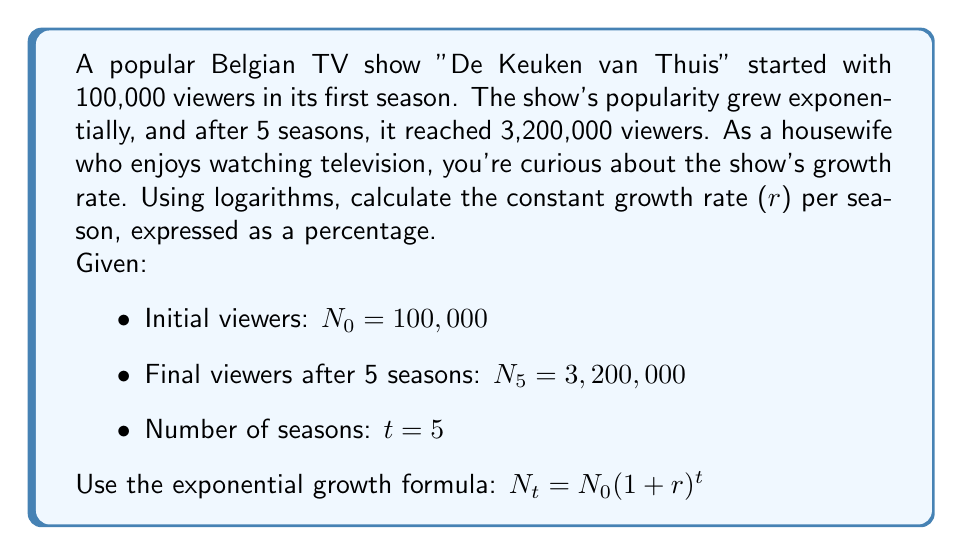Can you solve this math problem? Let's solve this step-by-step using logarithms:

1) Start with the exponential growth formula:
   $N_t = N_0(1+r)^t$

2) Substitute the known values:
   $3,200,000 = 100,000(1+r)^5$

3) Divide both sides by 100,000:
   $32 = (1+r)^5$

4) Take the natural logarithm of both sides:
   $\ln(32) = \ln((1+r)^5)$

5) Use the logarithm property $\ln(a^b) = b\ln(a)$:
   $\ln(32) = 5\ln(1+r)$

6) Divide both sides by 5:
   $\frac{\ln(32)}{5} = \ln(1+r)$

7) Apply the exponential function to both sides:
   $e^{\frac{\ln(32)}{5}} = e^{\ln(1+r)} = 1+r$

8) Subtract 1 from both sides:
   $e^{\frac{\ln(32)}{5}} - 1 = r$

9) Calculate the value:
   $r = e^{\frac{\ln(32)}{5}} - 1 \approx 0.2623$

10) Convert to a percentage:
    $r \approx 26.23\%$
Answer: The constant growth rate of the TV show "De Keuken van Thuis" is approximately 26.23% per season. 